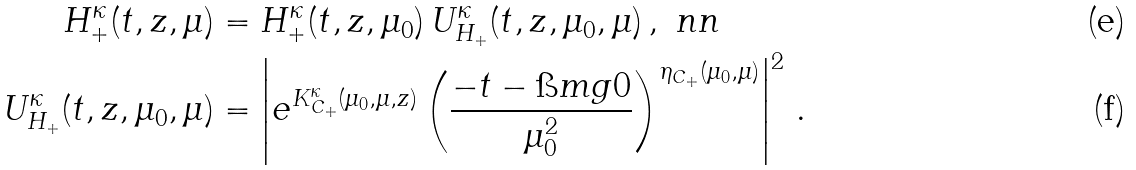Convert formula to latex. <formula><loc_0><loc_0><loc_500><loc_500>H _ { + } ^ { \kappa } ( t , z , \mu ) & = H _ { + } ^ { \kappa } ( t , z , \mu _ { 0 } ) \, U _ { H _ { + } } ^ { \kappa } ( t , z , \mu _ { 0 } , \mu ) \, , \ n n \\ U _ { H _ { + } } ^ { \kappa } ( t , z , \mu _ { 0 } , \mu ) & = \left | e ^ { K _ { C _ { + } } ^ { \kappa } ( \mu _ { 0 } , \mu , z ) } \left ( \frac { - t - \i m g 0 } { \mu _ { 0 } ^ { 2 } } \right ) ^ { \eta _ { C _ { + } } ( \mu _ { 0 } , \mu ) } \right | ^ { 2 } \, .</formula> 